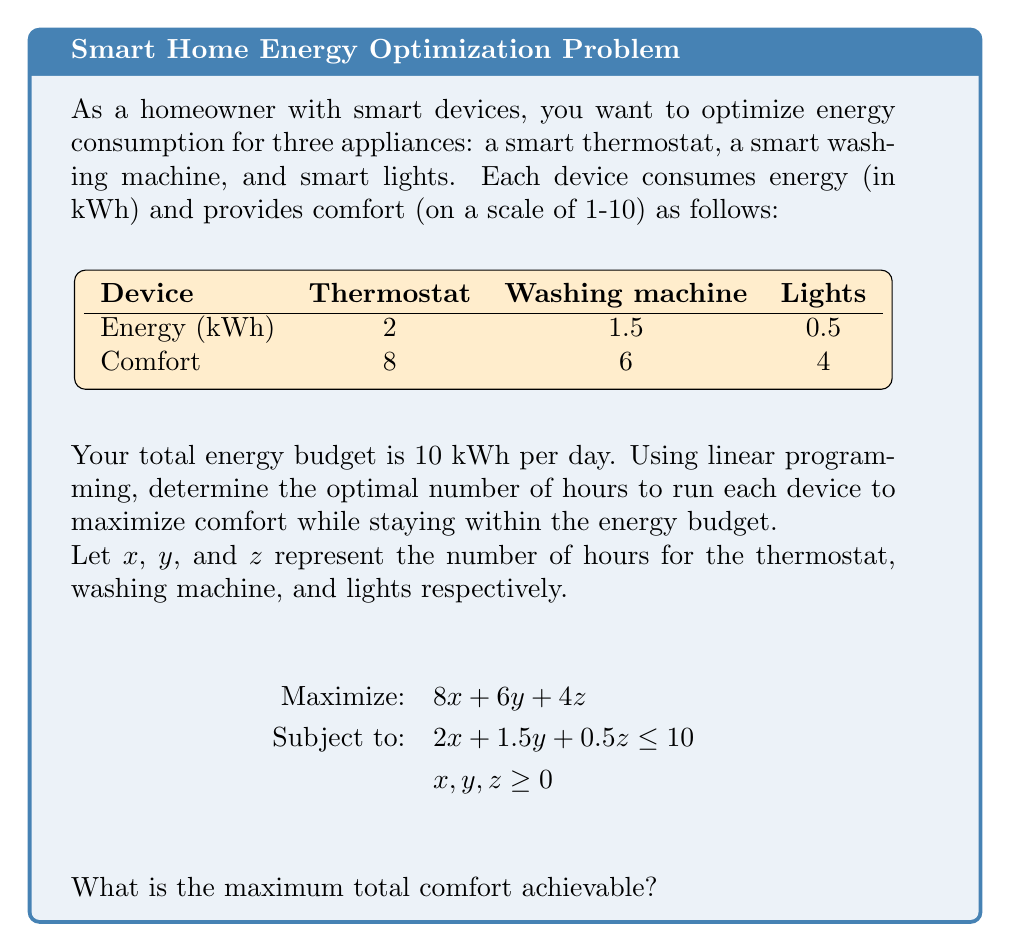Can you solve this math problem? To solve this linear programming problem, we'll use the graphical method:

1) First, plot the constraint:
   $2x + 1.5y + 0.5z = 10$

2) The feasible region is the area below this plane that satisfies $x, y, z \geq 0$.

3) The objective function to maximize is:
   $f(x,y,z) = 8x + 6y + 4z$

4) We need to find the point in the feasible region that maximizes this function.

5) In 3D space, the optimal solution will be at one of the vertices of the feasible region.

6) The vertices are:
   (5, 0, 0), (0, 6.67, 0), (0, 0, 20), (4, 1.33, 0), (3.33, 0, 6.67), (0, 5, 5)

7) Evaluate the objective function at each vertex:
   f(5, 0, 0) = 40
   f(0, 6.67, 0) ≈ 40
   f(0, 0, 20) = 80
   f(4, 1.33, 0) ≈ 40
   f(3.33, 0, 6.67) ≈ 53.33
   f(0, 5, 5) = 50

8) The maximum value is 80, achieved at (0, 0, 20).

Therefore, the maximum total comfort achievable is 80.
Answer: 80 